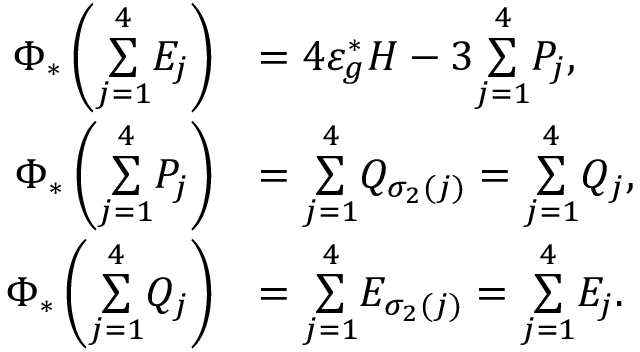Convert formula to latex. <formula><loc_0><loc_0><loc_500><loc_500>\begin{array} { r l r } { \Phi _ { * } \left ( \underset { j = 1 } { \overset { 4 } { \sum } } E _ { j } \right ) } & { = 4 \varepsilon _ { g } ^ { * } H - 3 \underset { j = 1 } { \overset { 4 } { \sum } } P _ { j } , } & \\ { \Phi _ { * } \left ( \underset { j = 1 } { \overset { 4 } { \sum } } P _ { j } \right ) } & { = \underset { j = 1 } { \overset { 4 } { \sum } } Q _ { \sigma _ { 2 } ( j ) } = \underset { j = 1 } { \overset { 4 } { \sum } } Q _ { j } , } & \\ { \Phi _ { * } \left ( \underset { j = 1 } { \overset { 4 } { \sum } } Q _ { j } \right ) } & { = \underset { j = 1 } { \overset { 4 } { \sum } } E _ { \sigma _ { 2 } ( j ) } = \underset { j = 1 } { \overset { 4 } { \sum } } E _ { j } . } \end{array}</formula> 